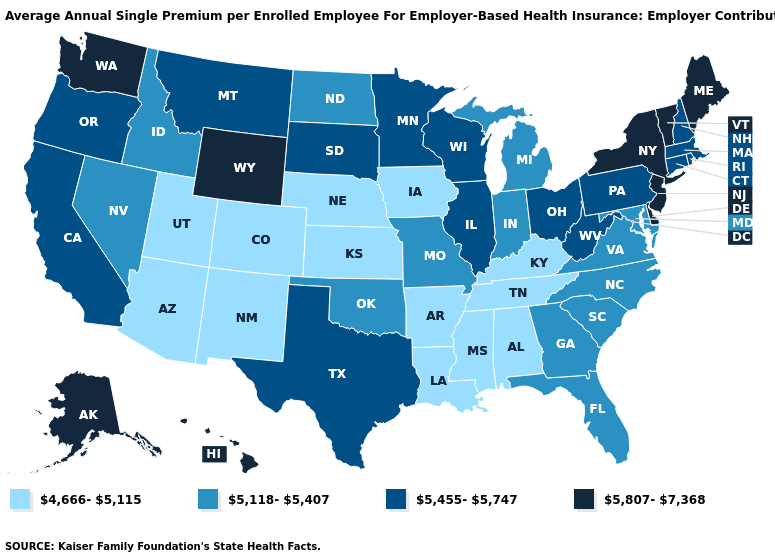What is the value of Mississippi?
Concise answer only. 4,666-5,115. What is the lowest value in the USA?
Be succinct. 4,666-5,115. Does Nebraska have the lowest value in the MidWest?
Write a very short answer. Yes. Name the states that have a value in the range 5,118-5,407?
Concise answer only. Florida, Georgia, Idaho, Indiana, Maryland, Michigan, Missouri, Nevada, North Carolina, North Dakota, Oklahoma, South Carolina, Virginia. Which states have the highest value in the USA?
Write a very short answer. Alaska, Delaware, Hawaii, Maine, New Jersey, New York, Vermont, Washington, Wyoming. What is the value of Washington?
Be succinct. 5,807-7,368. Does the map have missing data?
Short answer required. No. Does Virginia have the lowest value in the USA?
Be succinct. No. Name the states that have a value in the range 4,666-5,115?
Concise answer only. Alabama, Arizona, Arkansas, Colorado, Iowa, Kansas, Kentucky, Louisiana, Mississippi, Nebraska, New Mexico, Tennessee, Utah. What is the value of Alabama?
Quick response, please. 4,666-5,115. Among the states that border New Jersey , which have the highest value?
Quick response, please. Delaware, New York. Which states have the lowest value in the South?
Concise answer only. Alabama, Arkansas, Kentucky, Louisiana, Mississippi, Tennessee. Does Utah have the lowest value in the USA?
Write a very short answer. Yes. Does Massachusetts have the lowest value in the Northeast?
Give a very brief answer. Yes. Does New Mexico have the lowest value in the USA?
Write a very short answer. Yes. 